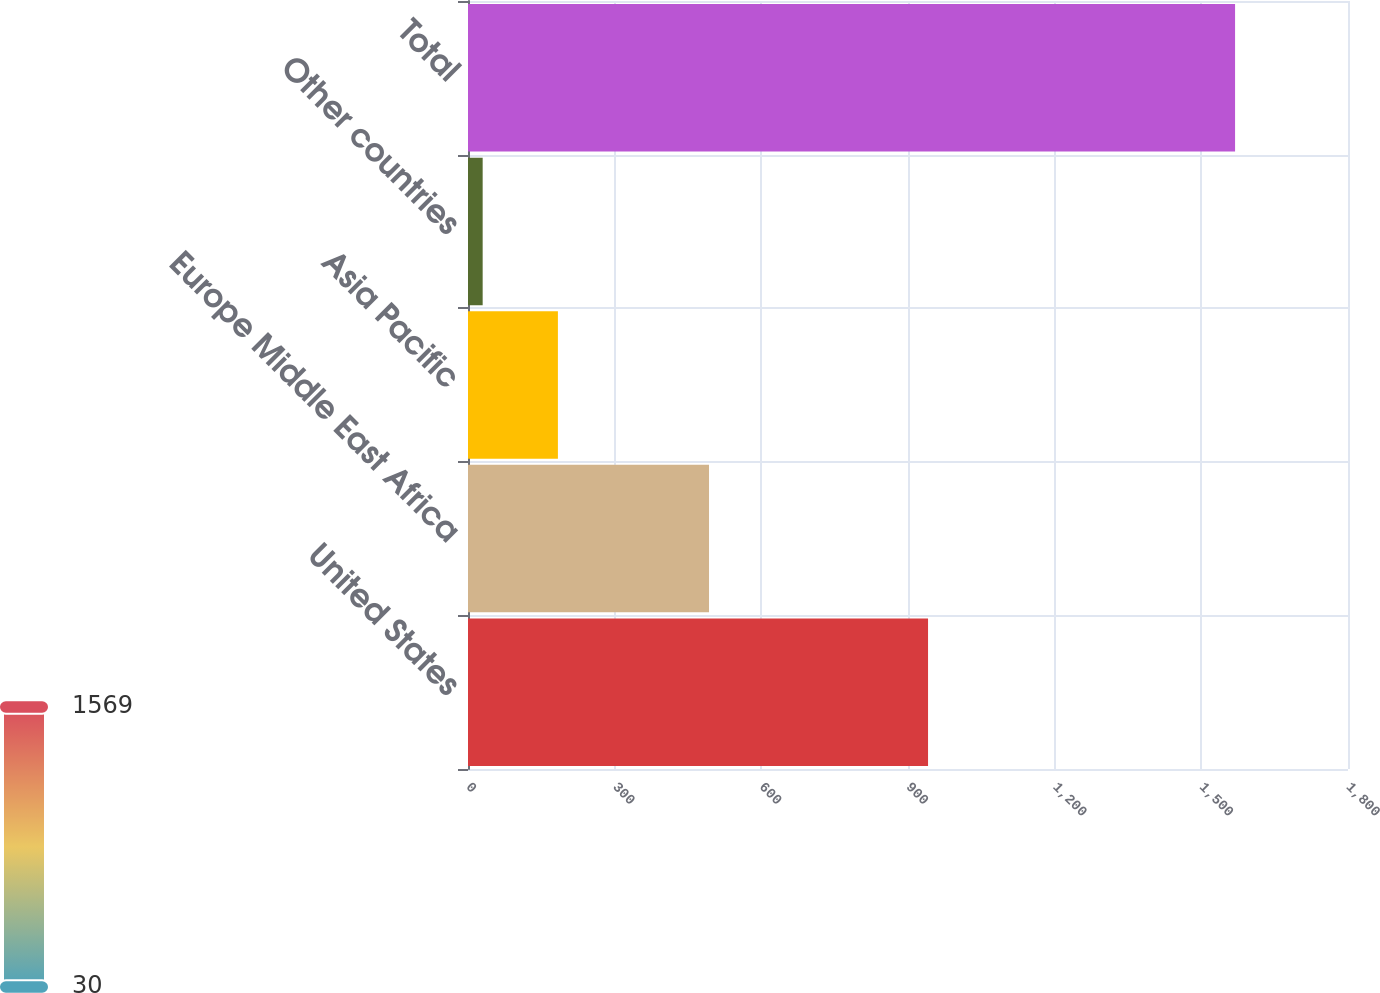<chart> <loc_0><loc_0><loc_500><loc_500><bar_chart><fcel>United States<fcel>Europe Middle East Africa<fcel>Asia Pacific<fcel>Other countries<fcel>Total<nl><fcel>941<fcel>493<fcel>183.9<fcel>30<fcel>1569<nl></chart> 